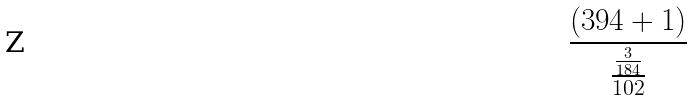Convert formula to latex. <formula><loc_0><loc_0><loc_500><loc_500>\frac { ( 3 9 4 + 1 ) } { \frac { \frac { 3 } { 1 8 4 } } { 1 0 2 } }</formula> 